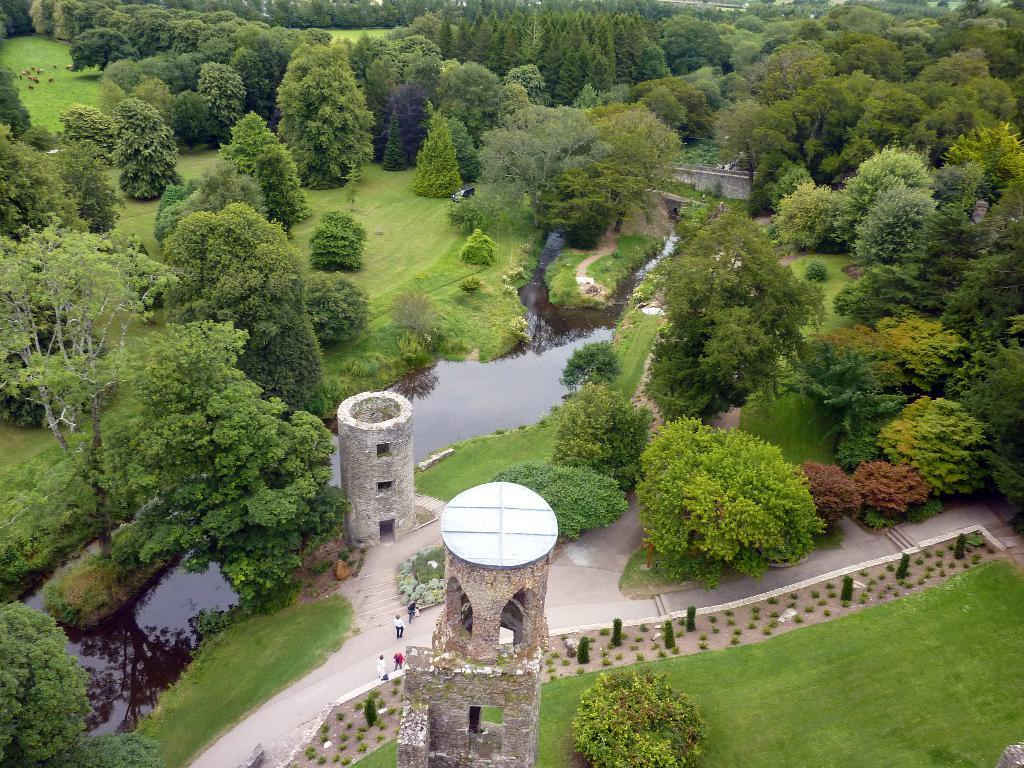What type of vegetation can be seen in the image? There are trees in the image. What else can be seen in the image besides trees? There is water and grass visible in the image. Are there any human figures in the image? Yes, there are people in the image. What type of structures are present in the image? There are concrete-towers in the image. Can you see a jar filled with skin in the image? There is no jar or skin present in the image. Is there an umbrella being used by any of the people in the image? There is no umbrella visible in the image. 